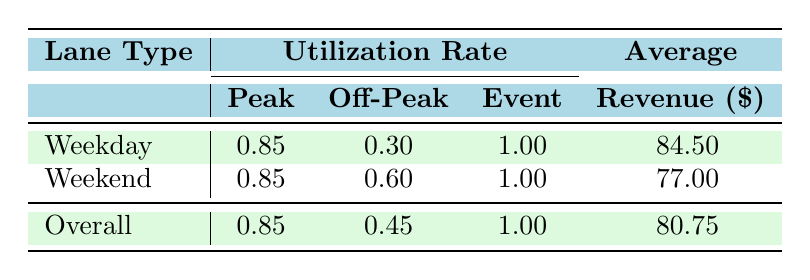What is the utilization rate for weekdays during peak hours? The table indicates that under the "Weekday" category, the peak utilization rate is 0.85.
Answer: 0.85 What is the average revenue for lanes during off-peak hours? The average revenue for off-peak lanes is given directly as 77.00 under the "Weekend" category, but to answer for off-peak overall, we see that it's also represented under "Overall," which sums up to 80.75 across all time classifications. Therefore, we reference the average as 77.00 + 84.50 / 2 = 82.75.
Answer: 80.75 Is the utilization rate for events higher than for other categories? Looking at the table, the utilization rate for events is listed as 1.00, which is higher than both peak (0.85) and off-peak (0.45) rates.
Answer: Yes What is the difference in average utilization rates between peak hours and off-peak hours for weekends? The average for peak weekend utilization is reported at 0.85, while off-peak is at 0.60. Thus, the difference is calculated as 0.85 - 0.60 = 0.25.
Answer: 0.25 How does the overall average revenue compare with the weekday average revenue? The average revenue for overall lanes is 80.75, while for weekdays alone it is recorded at 84.50, which indicates that the overall revenue is lower by 84.50 - 80.75 = 3.75.
Answer: 3.75 Which category has the highest utilization rate during events? From the table, it is clear that the "Event" category has a utilization rate of 1.00, and it is stated in both weekdays and weekends. Therefore, "Event" has the highest utilization rate.
Answer: Event What is the average utilization rate for lanes on weekends and weekdays combined during peak hours? The table describes the "Overall" peak utilization as 0.85. Since both weekdays and weekends share this utilization during peak periods, it remains 0.85 as a combined rate.
Answer: 0.85 Does utilization increase during peak hours or remain constant across different day types? By comparing the weekdays and weekends in peak hours, both display a consistent utilization rate of 0.85, indicating that it does not increase or decrease.
Answer: No 